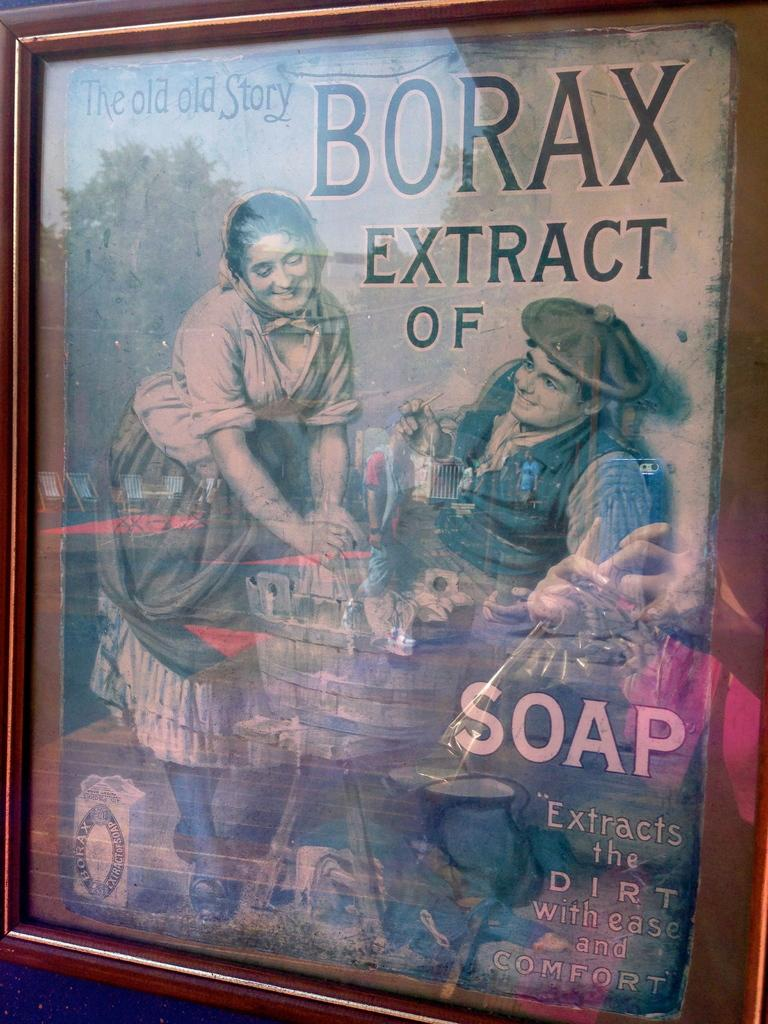<image>
Create a compact narrative representing the image presented. A vintage ad for Borax Soap showing a washerwoman. 